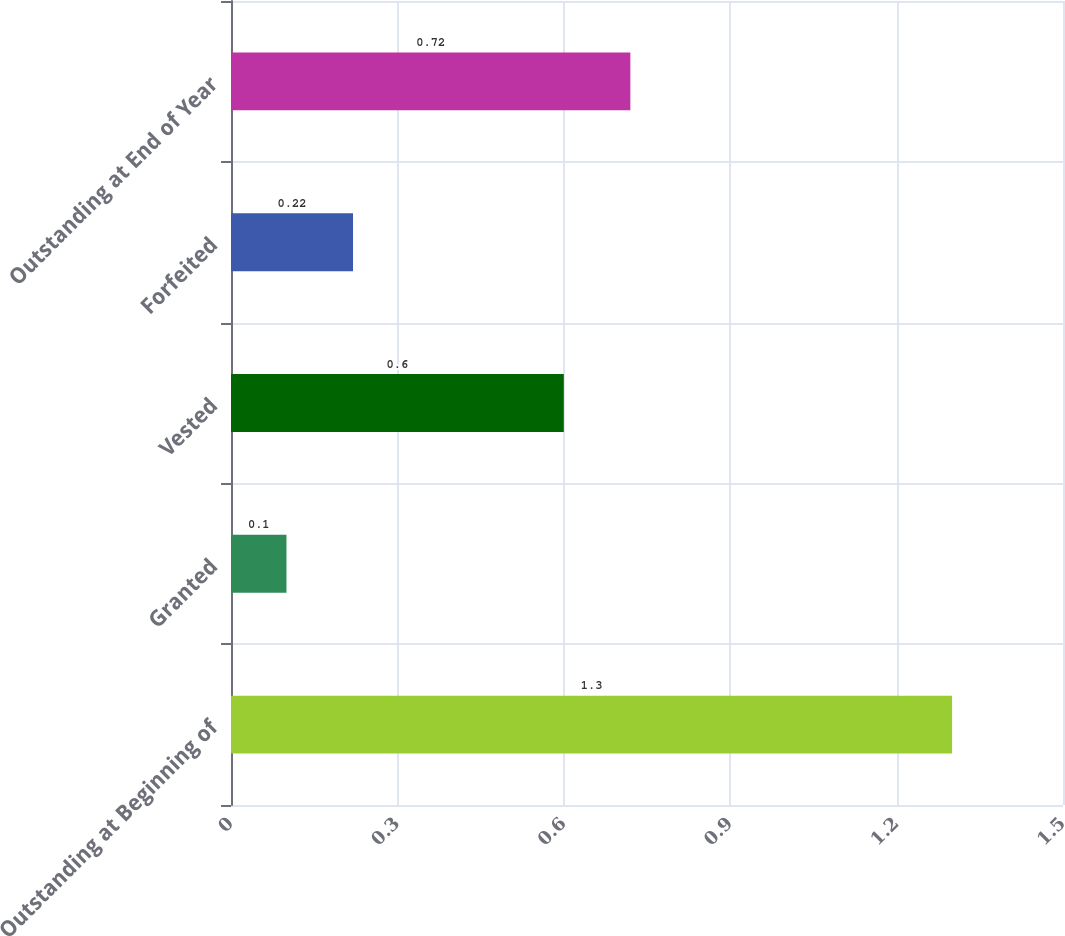Convert chart to OTSL. <chart><loc_0><loc_0><loc_500><loc_500><bar_chart><fcel>Outstanding at Beginning of<fcel>Granted<fcel>Vested<fcel>Forfeited<fcel>Outstanding at End of Year<nl><fcel>1.3<fcel>0.1<fcel>0.6<fcel>0.22<fcel>0.72<nl></chart> 